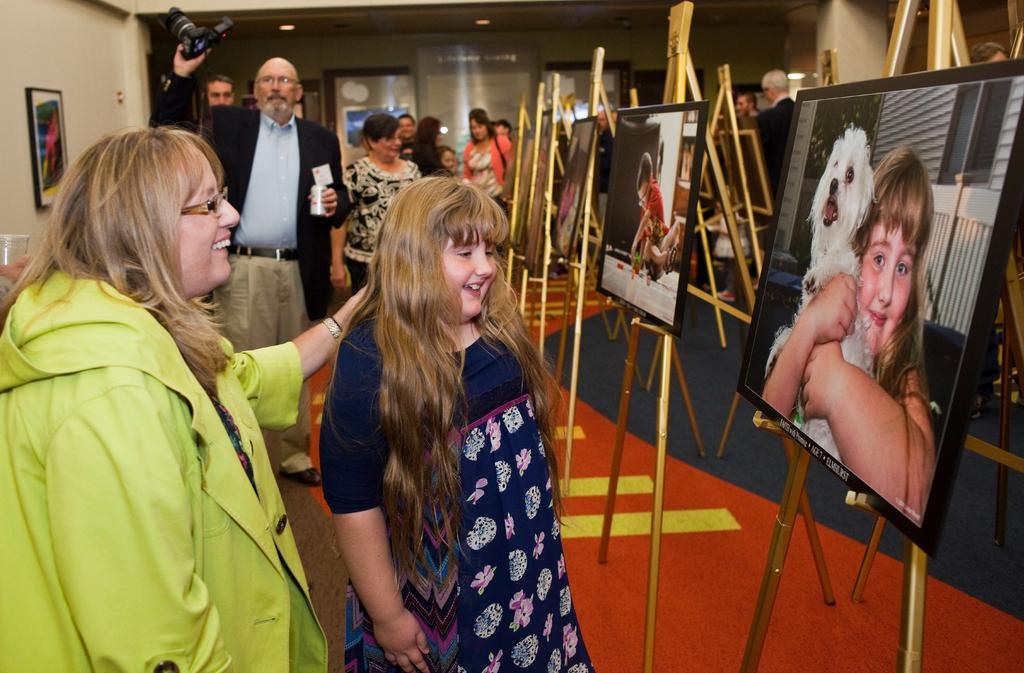What is happening in the image? There are people standing in the image, and there are people watching them. What objects can be seen in the image? There are photo frames in the image. What is the man holding in his hand? The man is holding a camera in his hand. What type of surprise is the man holding in his hand? The man is not holding a surprise in his hand; he is holding a camera. How does the death of the person in the image affect the scene? There is no indication of death in the image; it features people standing and watching, as well as photo frames and a man holding a camera. 